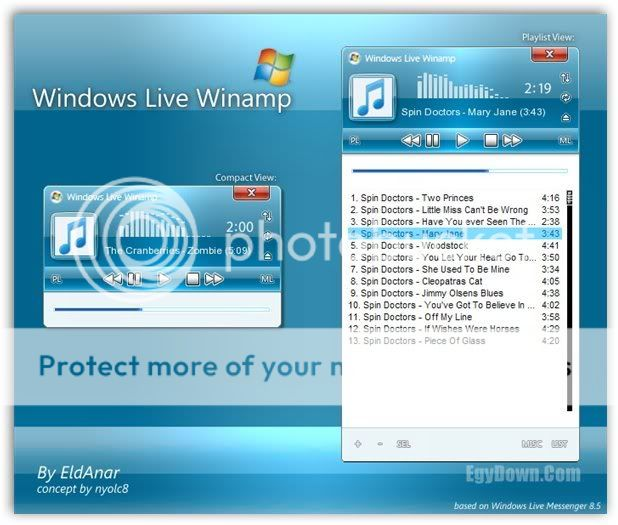Considering the highlighted track "Mary Jane" by Spin Doctors, is there any visual indication that this track is currently being played, and if so, what is it? Yes, there is a visual indication that the track "Mary Jane" by Spin Doctors is currently being played. The track is highlighted in the playlist, which is a common graphical user interface convention to indicate selection or activity. Additionally, the media player controls on the right window are in an active state, with the pause button visible, suggesting that playback is in progress. The progress bar also shows some advancement, and the time indicator is at 2:19, which aligns with the duration of a track that would be playing. These elements together suggest that "Mary Jane" is the track currently playing. 